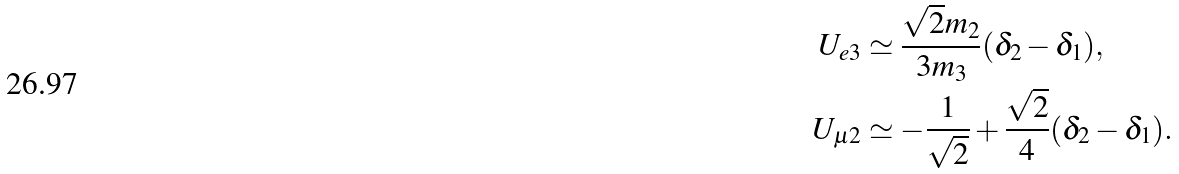<formula> <loc_0><loc_0><loc_500><loc_500>U _ { e 3 } & \simeq \frac { \sqrt { 2 } m _ { 2 } } { 3 m _ { 3 } } ( \delta _ { 2 } - \delta _ { 1 } ) , \\ U _ { \mu 2 } & \simeq - \frac { 1 } { \sqrt { 2 } } + \frac { \sqrt { 2 } } { 4 } ( \delta _ { 2 } - \delta _ { 1 } ) .</formula> 